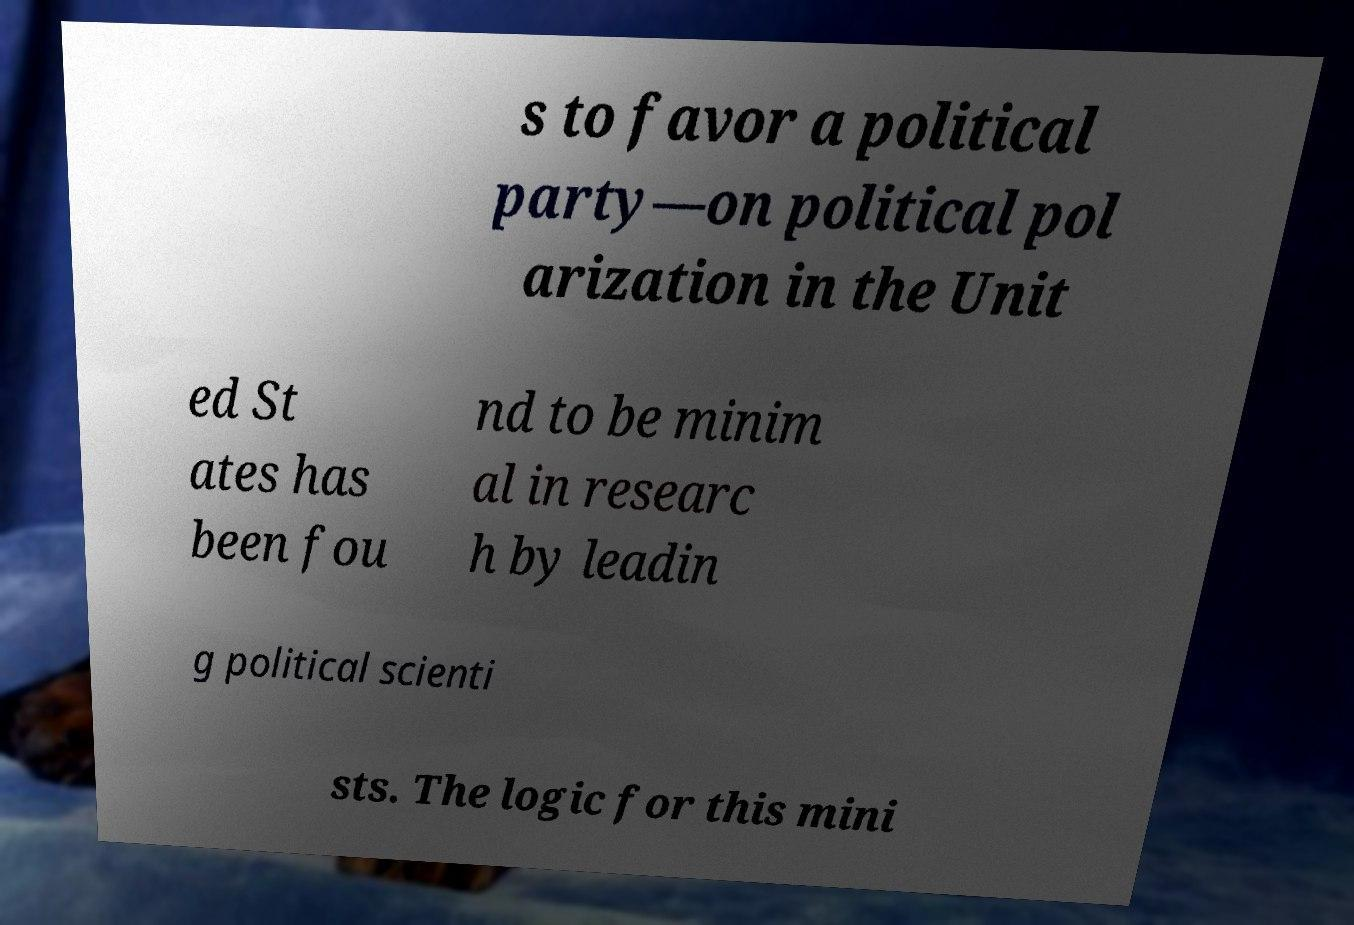Can you accurately transcribe the text from the provided image for me? s to favor a political party—on political pol arization in the Unit ed St ates has been fou nd to be minim al in researc h by leadin g political scienti sts. The logic for this mini 